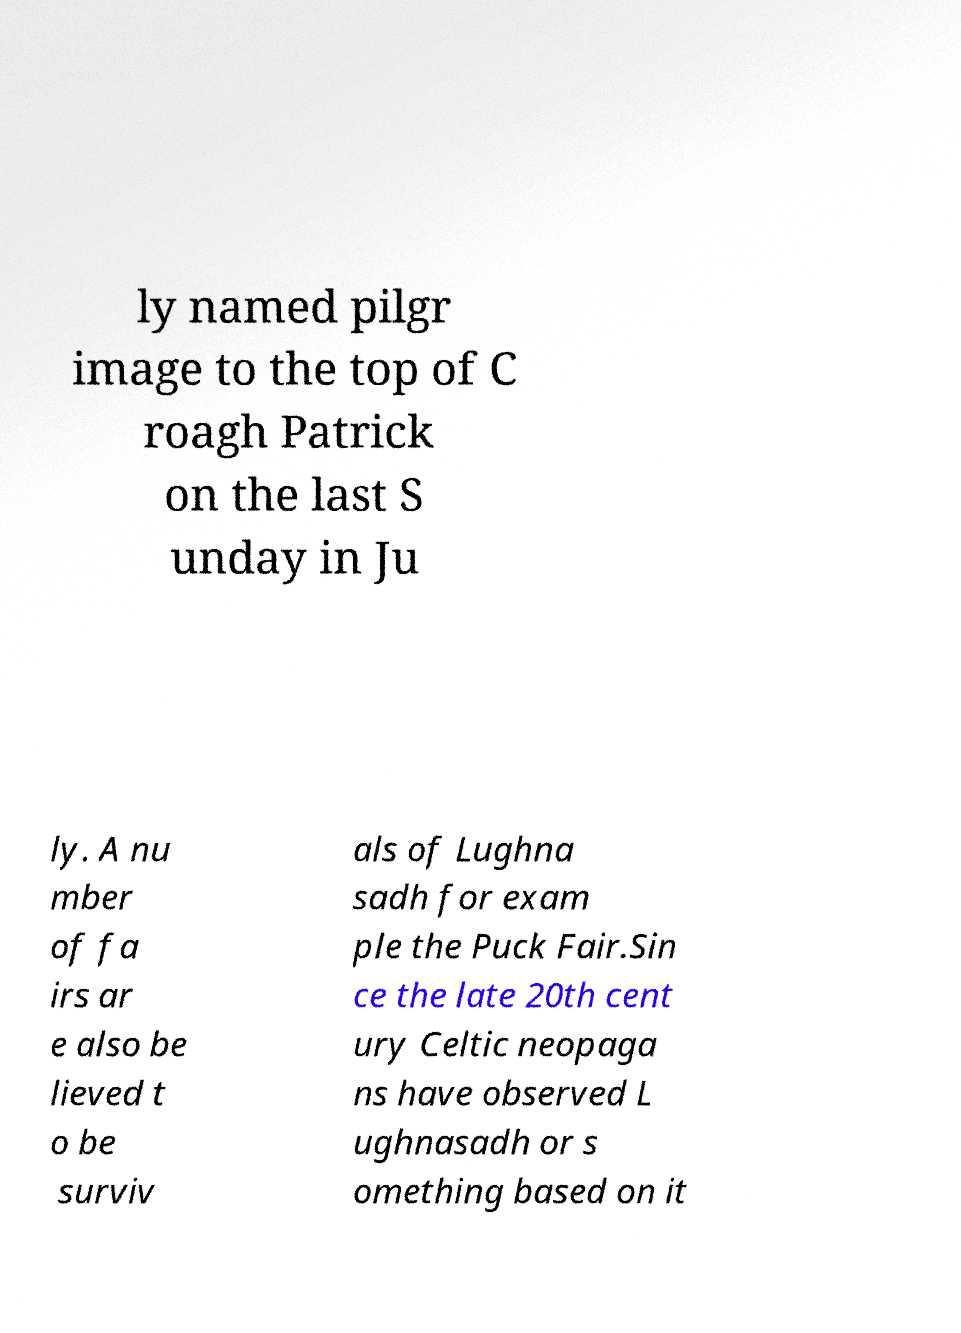Could you extract and type out the text from this image? ly named pilgr image to the top of C roagh Patrick on the last S unday in Ju ly. A nu mber of fa irs ar e also be lieved t o be surviv als of Lughna sadh for exam ple the Puck Fair.Sin ce the late 20th cent ury Celtic neopaga ns have observed L ughnasadh or s omething based on it 